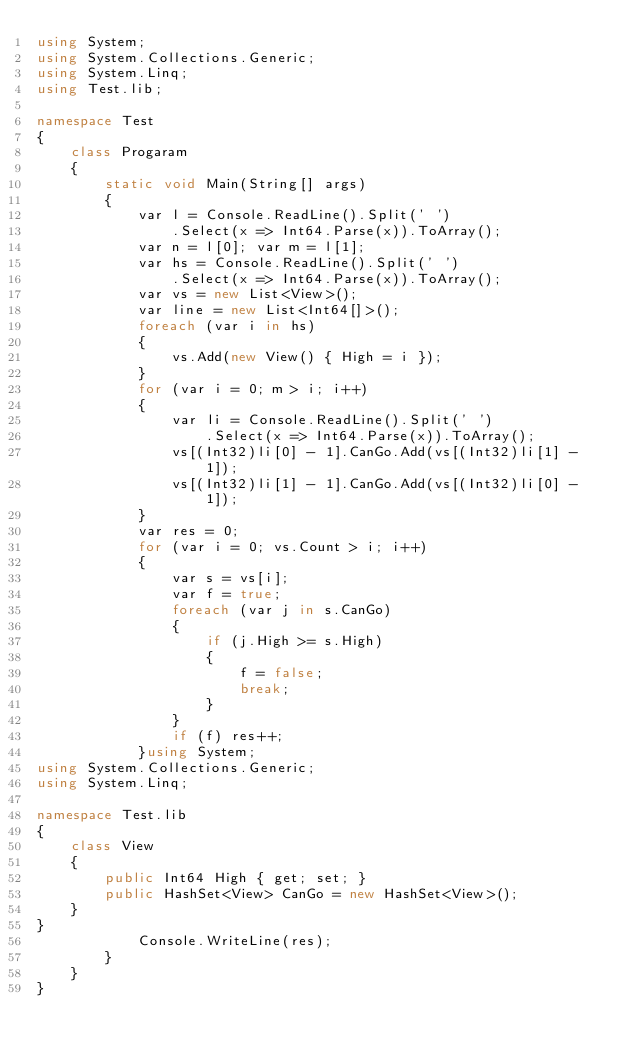Convert code to text. <code><loc_0><loc_0><loc_500><loc_500><_C#_>using System;
using System.Collections.Generic;
using System.Linq;
using Test.lib;

namespace Test
{
    class Progaram
    {
        static void Main(String[] args)
        {
            var l = Console.ReadLine().Split(' ')
                .Select(x => Int64.Parse(x)).ToArray();
            var n = l[0]; var m = l[1];
            var hs = Console.ReadLine().Split(' ')
                .Select(x => Int64.Parse(x)).ToArray();
            var vs = new List<View>();
            var line = new List<Int64[]>();
            foreach (var i in hs)
            {
                vs.Add(new View() { High = i });
            }
            for (var i = 0; m > i; i++)
            {
                var li = Console.ReadLine().Split(' ')
                    .Select(x => Int64.Parse(x)).ToArray();
                vs[(Int32)li[0] - 1].CanGo.Add(vs[(Int32)li[1] - 1]);
                vs[(Int32)li[1] - 1].CanGo.Add(vs[(Int32)li[0] - 1]);
            }
            var res = 0;
            for (var i = 0; vs.Count > i; i++)
            {
                var s = vs[i];
                var f = true;
                foreach (var j in s.CanGo)
                {
                    if (j.High >= s.High)
                    {
                        f = false;
                        break;
                    }
                }
                if (f) res++;
            }using System;
using System.Collections.Generic;
using System.Linq;

namespace Test.lib
{
    class View
    {
        public Int64 High { get; set; }
        public HashSet<View> CanGo = new HashSet<View>();
    }
}
            Console.WriteLine(res);
        }
    }
}
</code> 